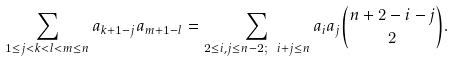Convert formula to latex. <formula><loc_0><loc_0><loc_500><loc_500>\sum _ { 1 \leq j < k < l < m \leq n } a _ { k + 1 - j } a _ { m + 1 - l } = \sum _ { 2 \leq i , j \leq n - 2 ; \ i + j \leq n } a _ { i } a _ { j } \binom { n + 2 - i - j } { 2 } .</formula> 